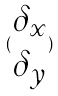<formula> <loc_0><loc_0><loc_500><loc_500>( \begin{matrix} \delta _ { x } \\ \delta _ { y } \end{matrix} )</formula> 